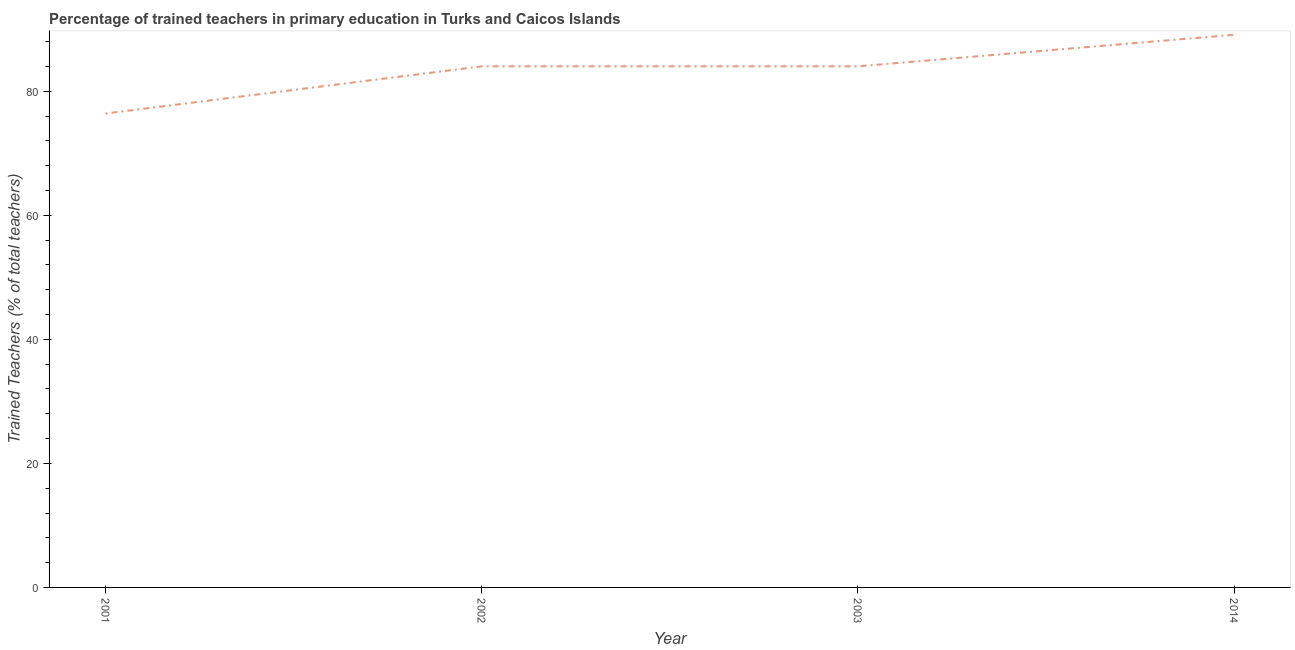What is the percentage of trained teachers in 2014?
Offer a very short reply. 89.12. Across all years, what is the maximum percentage of trained teachers?
Offer a very short reply. 89.12. Across all years, what is the minimum percentage of trained teachers?
Keep it short and to the point. 76.42. In which year was the percentage of trained teachers maximum?
Ensure brevity in your answer.  2014. In which year was the percentage of trained teachers minimum?
Give a very brief answer. 2001. What is the sum of the percentage of trained teachers?
Make the answer very short. 333.61. What is the difference between the percentage of trained teachers in 2003 and 2014?
Provide a short and direct response. -5.09. What is the average percentage of trained teachers per year?
Your answer should be very brief. 83.4. What is the median percentage of trained teachers?
Your answer should be very brief. 84.03. In how many years, is the percentage of trained teachers greater than 72 %?
Offer a very short reply. 4. What is the ratio of the percentage of trained teachers in 2001 to that in 2003?
Provide a short and direct response. 0.91. What is the difference between the highest and the second highest percentage of trained teachers?
Make the answer very short. 5.09. Is the sum of the percentage of trained teachers in 2002 and 2014 greater than the maximum percentage of trained teachers across all years?
Your answer should be very brief. Yes. What is the difference between the highest and the lowest percentage of trained teachers?
Your answer should be very brief. 12.7. In how many years, is the percentage of trained teachers greater than the average percentage of trained teachers taken over all years?
Make the answer very short. 3. What is the difference between two consecutive major ticks on the Y-axis?
Your answer should be compact. 20. Does the graph contain any zero values?
Keep it short and to the point. No. Does the graph contain grids?
Give a very brief answer. No. What is the title of the graph?
Your answer should be very brief. Percentage of trained teachers in primary education in Turks and Caicos Islands. What is the label or title of the Y-axis?
Provide a short and direct response. Trained Teachers (% of total teachers). What is the Trained Teachers (% of total teachers) of 2001?
Make the answer very short. 76.42. What is the Trained Teachers (% of total teachers) of 2002?
Provide a succinct answer. 84.03. What is the Trained Teachers (% of total teachers) in 2003?
Provide a succinct answer. 84.03. What is the Trained Teachers (% of total teachers) in 2014?
Provide a short and direct response. 89.12. What is the difference between the Trained Teachers (% of total teachers) in 2001 and 2002?
Provide a short and direct response. -7.61. What is the difference between the Trained Teachers (% of total teachers) in 2001 and 2003?
Give a very brief answer. -7.61. What is the difference between the Trained Teachers (% of total teachers) in 2001 and 2014?
Offer a very short reply. -12.7. What is the difference between the Trained Teachers (% of total teachers) in 2002 and 2003?
Your response must be concise. 0. What is the difference between the Trained Teachers (% of total teachers) in 2002 and 2014?
Your response must be concise. -5.09. What is the difference between the Trained Teachers (% of total teachers) in 2003 and 2014?
Provide a short and direct response. -5.09. What is the ratio of the Trained Teachers (% of total teachers) in 2001 to that in 2002?
Your response must be concise. 0.91. What is the ratio of the Trained Teachers (% of total teachers) in 2001 to that in 2003?
Give a very brief answer. 0.91. What is the ratio of the Trained Teachers (% of total teachers) in 2001 to that in 2014?
Give a very brief answer. 0.86. What is the ratio of the Trained Teachers (% of total teachers) in 2002 to that in 2014?
Give a very brief answer. 0.94. What is the ratio of the Trained Teachers (% of total teachers) in 2003 to that in 2014?
Keep it short and to the point. 0.94. 